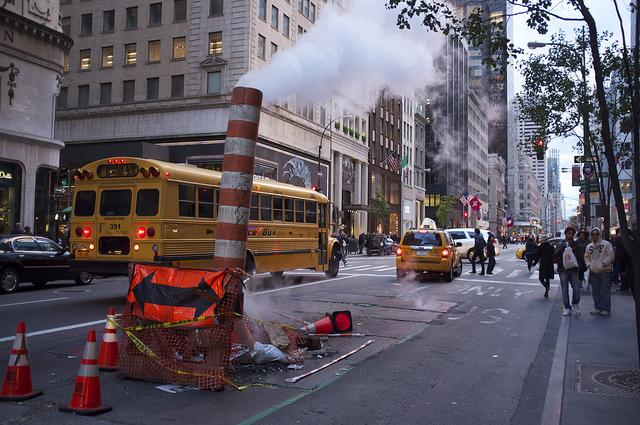What is the long vehicle for? transporting children 